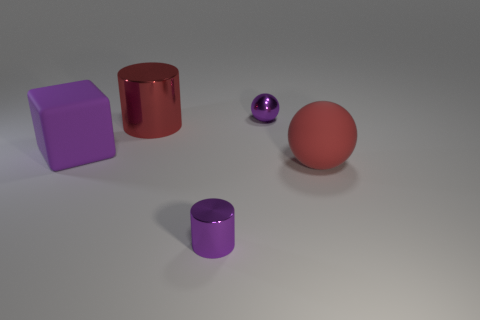Add 2 big red objects. How many objects exist? 7 Subtract all red spheres. How many spheres are left? 1 Subtract 1 spheres. How many spheres are left? 1 Subtract all purple metallic cylinders. Subtract all purple metal cylinders. How many objects are left? 3 Add 1 tiny cylinders. How many tiny cylinders are left? 2 Add 1 tiny purple shiny cylinders. How many tiny purple shiny cylinders exist? 2 Subtract 0 gray spheres. How many objects are left? 5 Subtract all cylinders. How many objects are left? 3 Subtract all yellow cylinders. Subtract all blue balls. How many cylinders are left? 2 Subtract all blue spheres. How many red cylinders are left? 1 